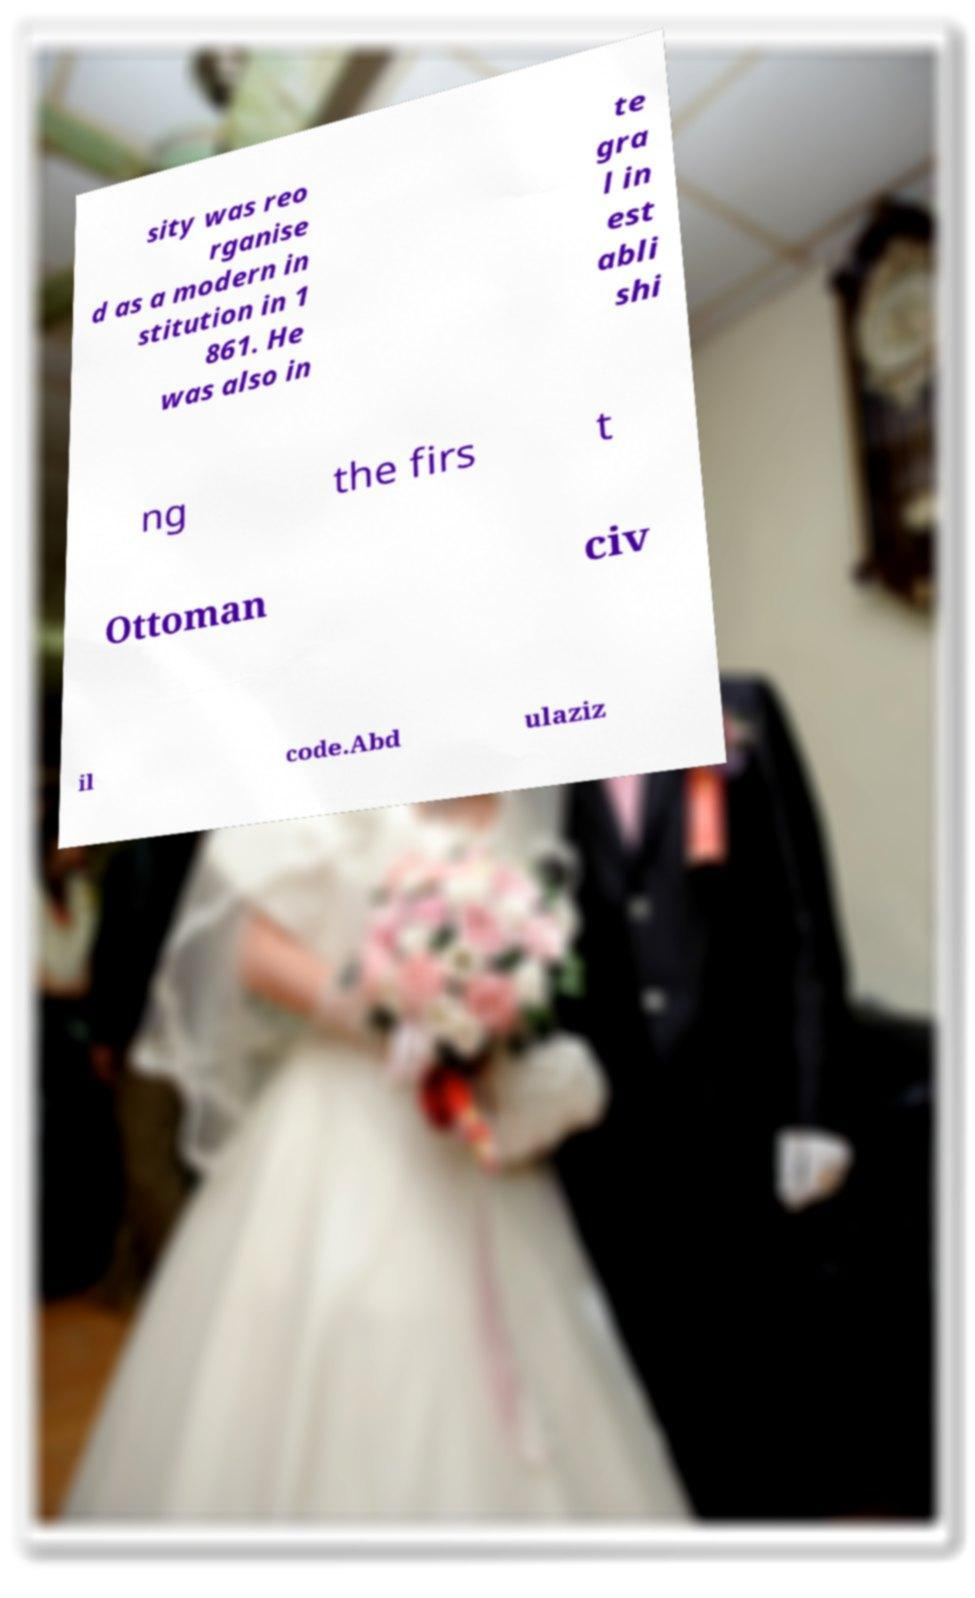Can you accurately transcribe the text from the provided image for me? sity was reo rganise d as a modern in stitution in 1 861. He was also in te gra l in est abli shi ng the firs t Ottoman civ il code.Abd ulaziz 